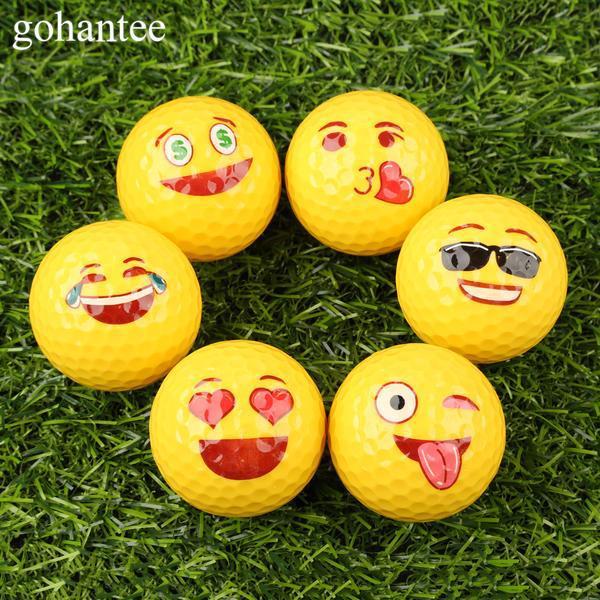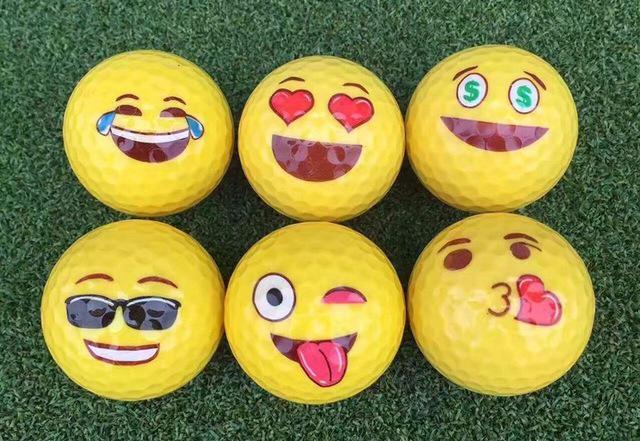The first image is the image on the left, the second image is the image on the right. Evaluate the accuracy of this statement regarding the images: "There is an open ball with something inside it in the left image, but not in the right.". Is it true? Answer yes or no. No. The first image is the image on the left, the second image is the image on the right. Evaluate the accuracy of this statement regarding the images: "At least some of the balls are made to look like emojis.". Is it true? Answer yes or no. Yes. 